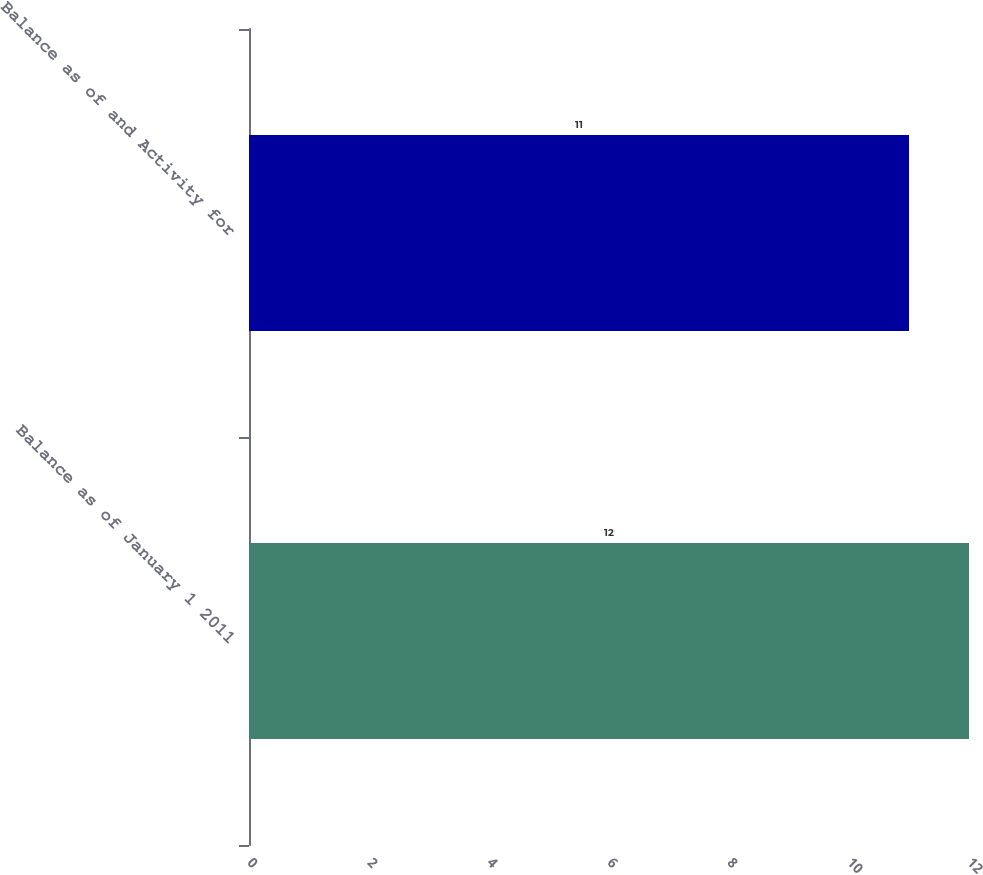Convert chart to OTSL. <chart><loc_0><loc_0><loc_500><loc_500><bar_chart><fcel>Balance as of January 1 2011<fcel>Balance as of and Activity for<nl><fcel>12<fcel>11<nl></chart> 